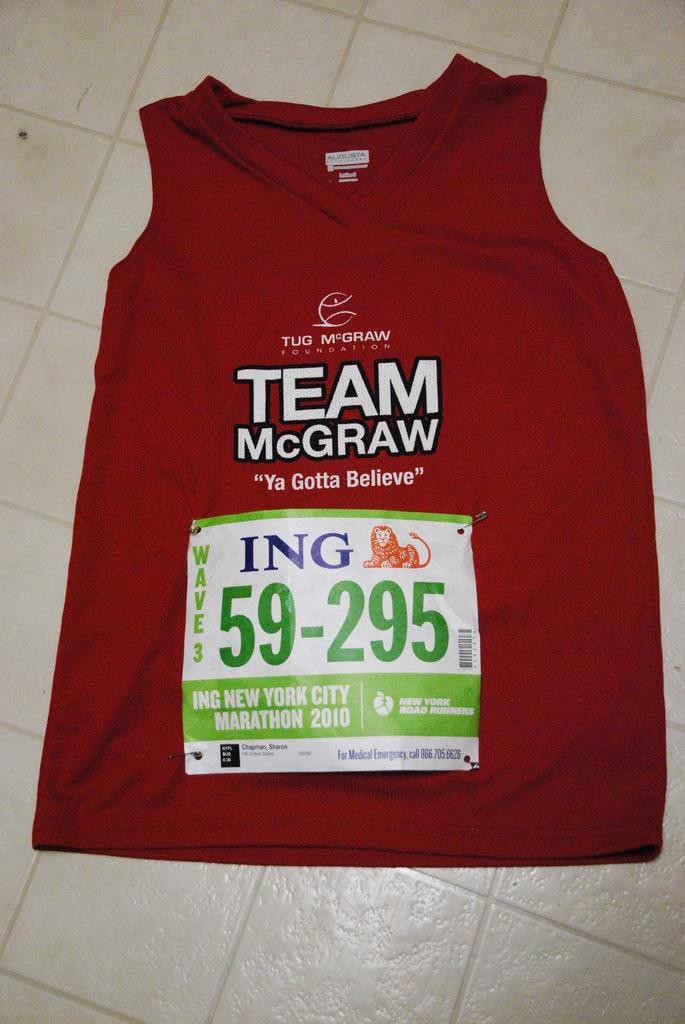Provide a one-sentence caption for the provided image. A red TEAM McGRAW shirt is labelled with the number 59-295. 